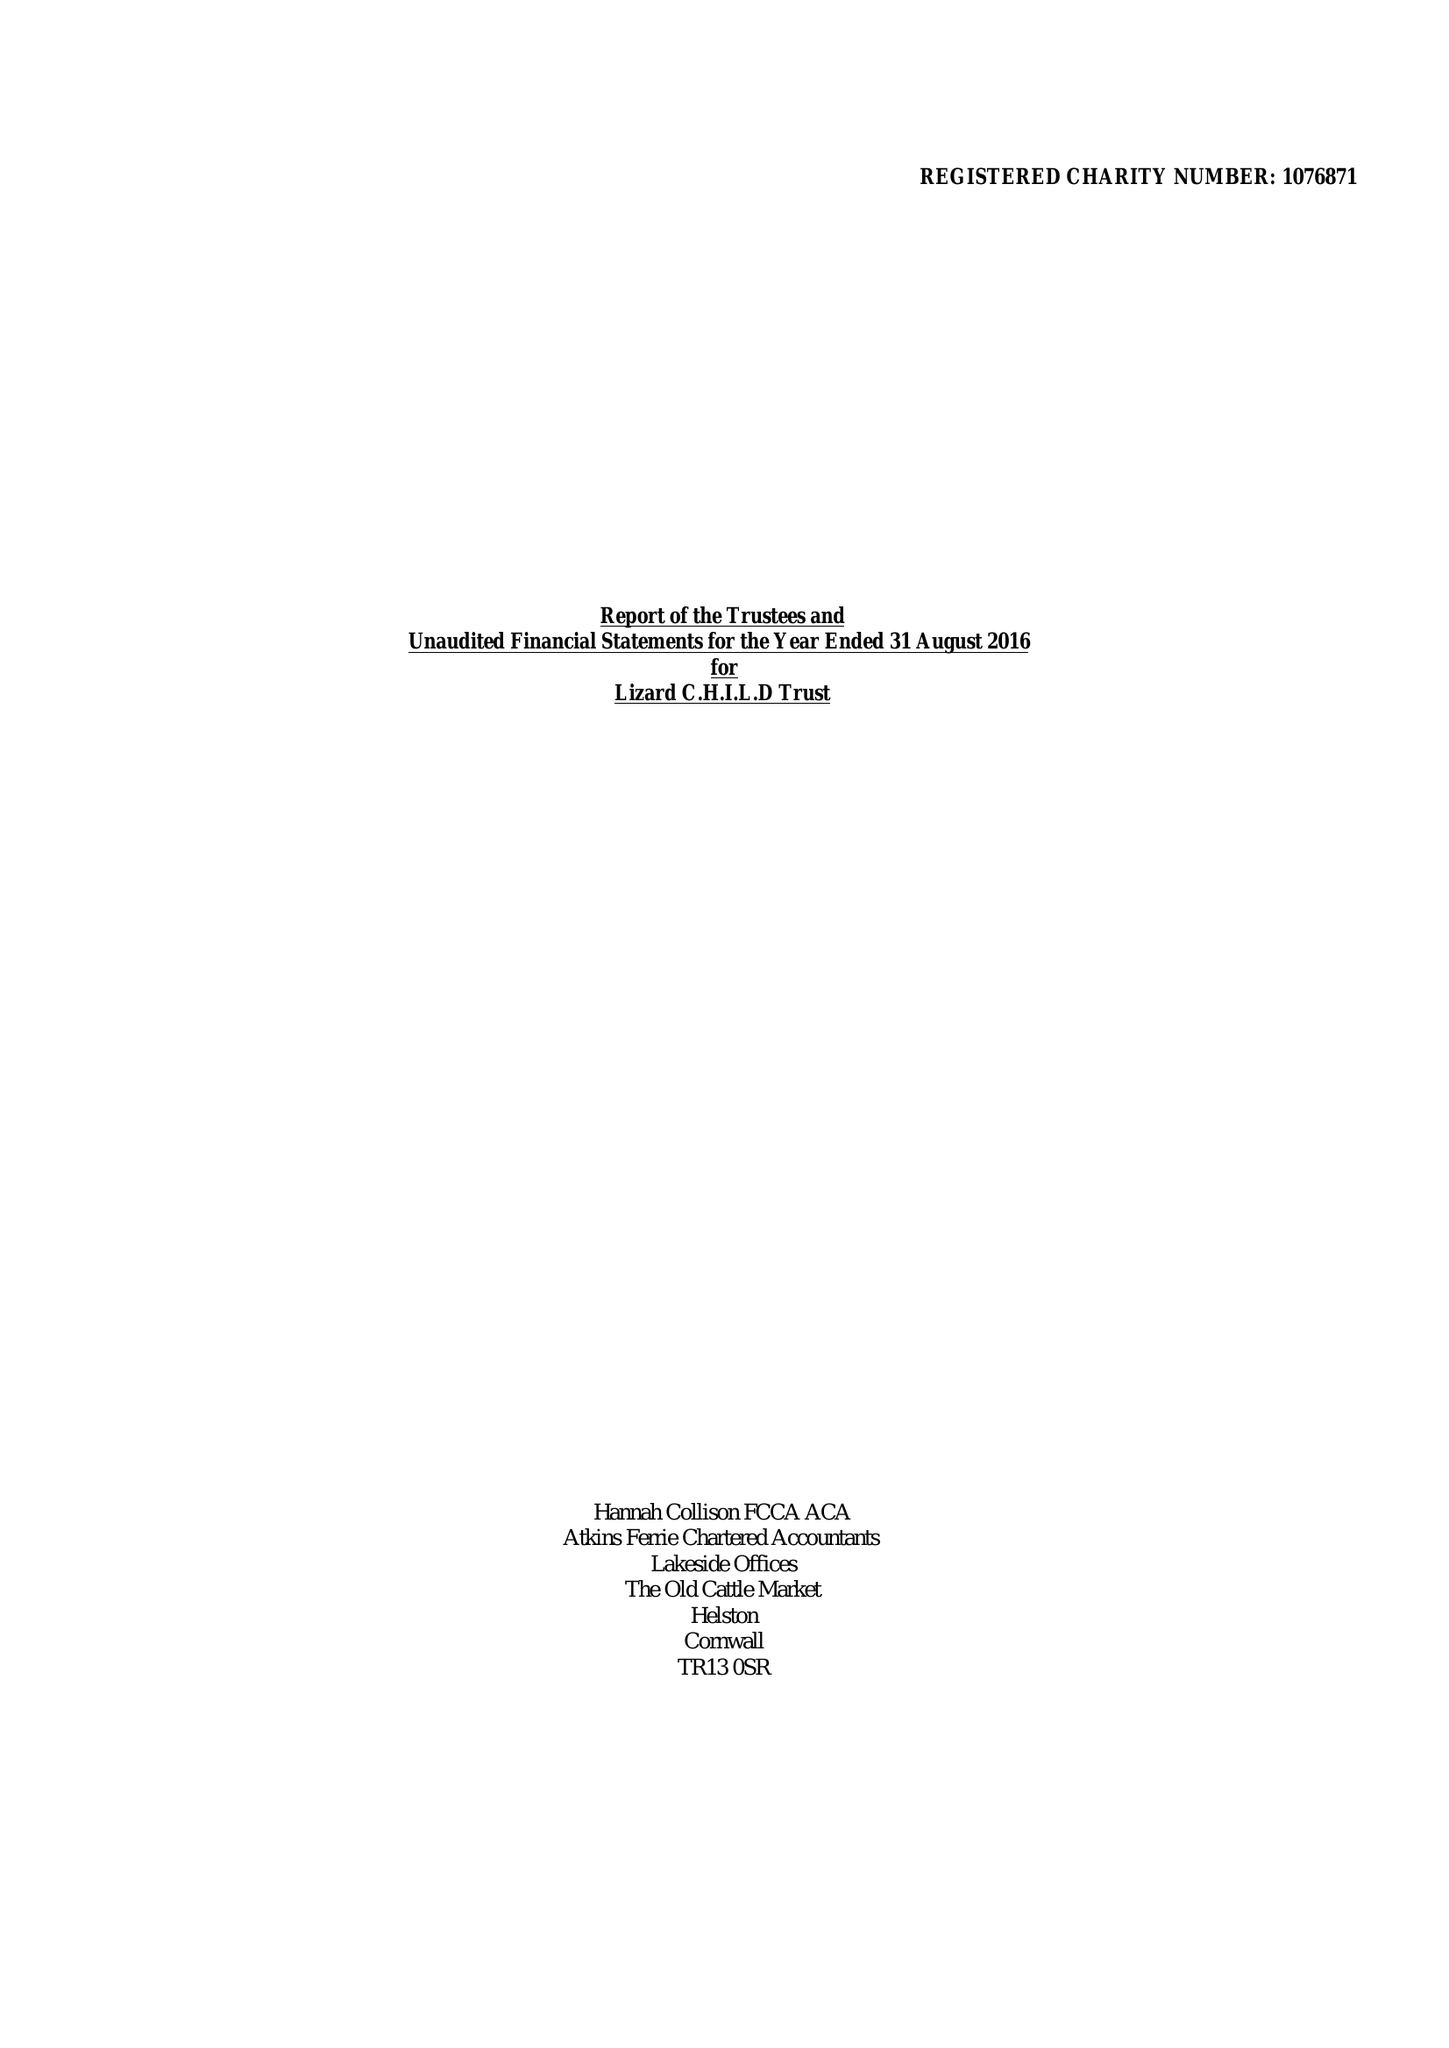What is the value for the charity_number?
Answer the question using a single word or phrase. 1076871 